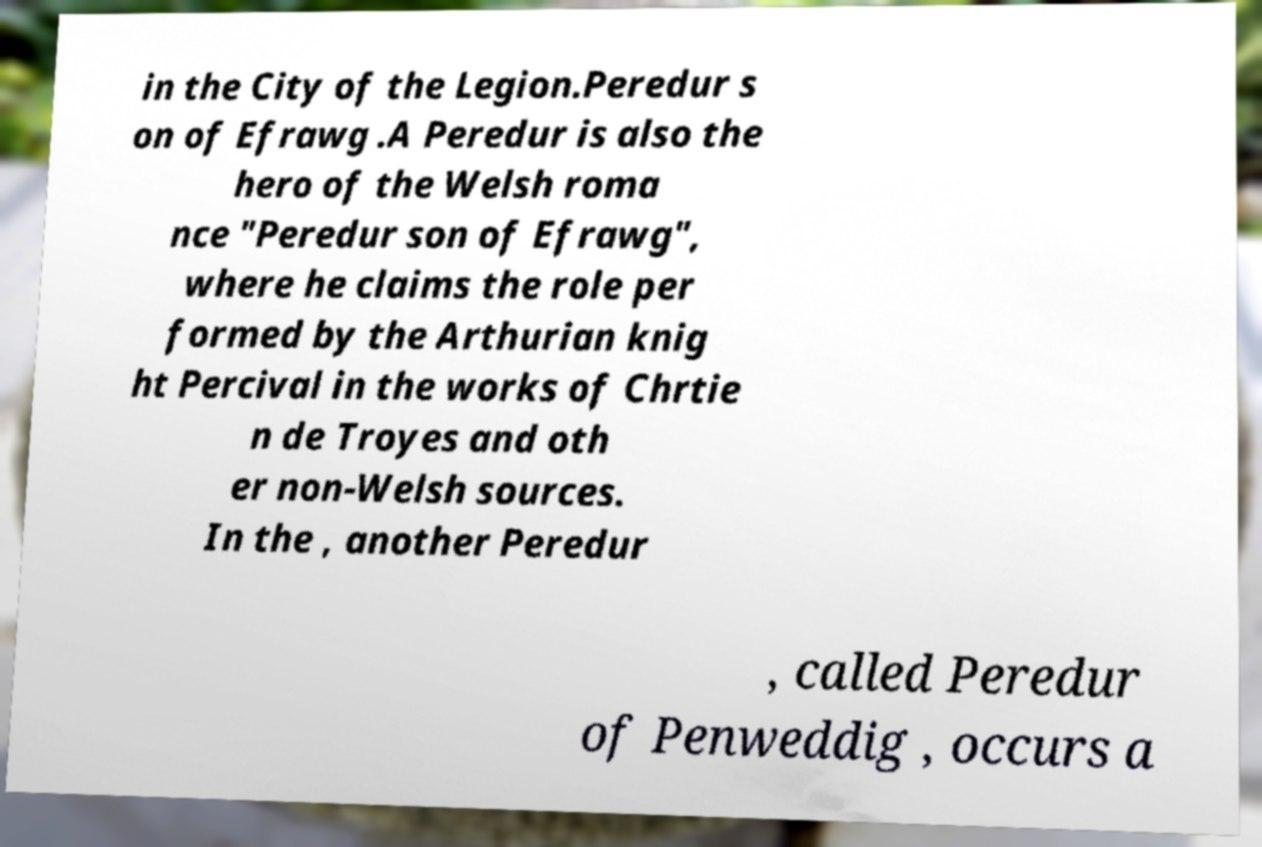What messages or text are displayed in this image? I need them in a readable, typed format. in the City of the Legion.Peredur s on of Efrawg .A Peredur is also the hero of the Welsh roma nce "Peredur son of Efrawg", where he claims the role per formed by the Arthurian knig ht Percival in the works of Chrtie n de Troyes and oth er non-Welsh sources. In the , another Peredur , called Peredur of Penweddig , occurs a 